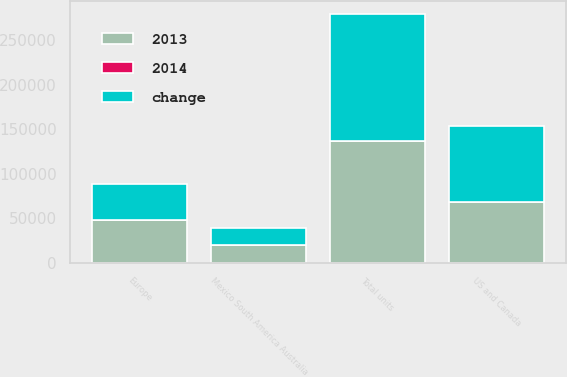<chart> <loc_0><loc_0><loc_500><loc_500><stacked_bar_chart><ecel><fcel>US and Canada<fcel>Europe<fcel>Mexico South America Australia<fcel>Total units<nl><fcel>change<fcel>84800<fcel>39500<fcel>18600<fcel>142900<nl><fcel>2013<fcel>68700<fcel>48400<fcel>20000<fcel>137100<nl><fcel>2014<fcel>23<fcel>18<fcel>7<fcel>4<nl></chart> 